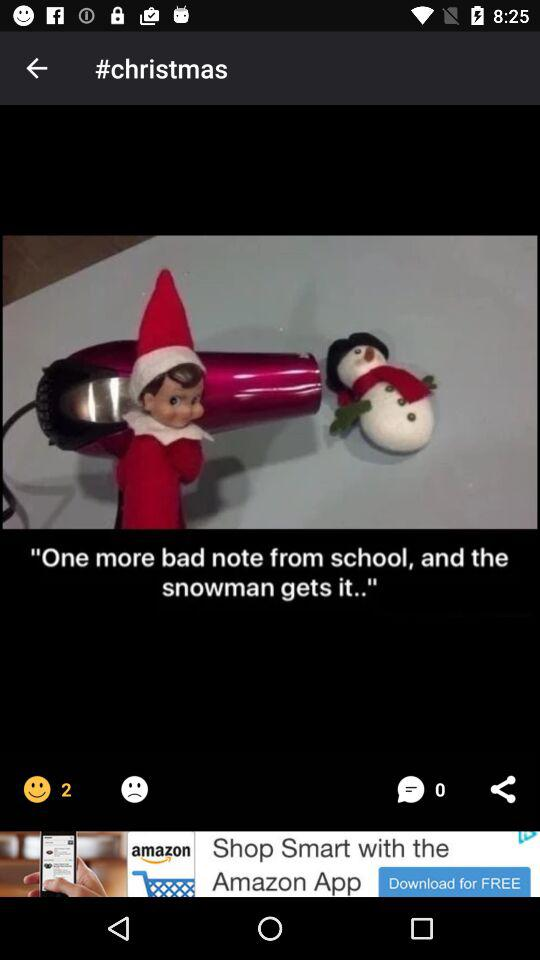How many comments are there? There are 0 comments. 